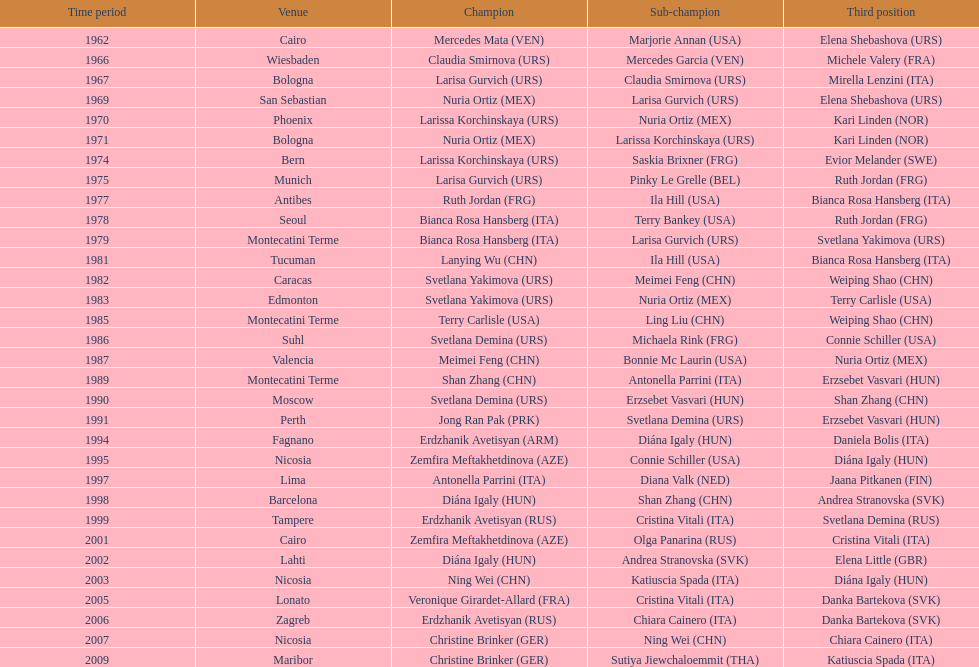Would you mind parsing the complete table? {'header': ['Time period', 'Venue', 'Champion', 'Sub-champion', 'Third position'], 'rows': [['1962', 'Cairo', 'Mercedes Mata\xa0(VEN)', 'Marjorie Annan\xa0(USA)', 'Elena Shebashova\xa0(URS)'], ['1966', 'Wiesbaden', 'Claudia Smirnova\xa0(URS)', 'Mercedes Garcia\xa0(VEN)', 'Michele Valery\xa0(FRA)'], ['1967', 'Bologna', 'Larisa Gurvich\xa0(URS)', 'Claudia Smirnova\xa0(URS)', 'Mirella Lenzini\xa0(ITA)'], ['1969', 'San Sebastian', 'Nuria Ortiz\xa0(MEX)', 'Larisa Gurvich\xa0(URS)', 'Elena Shebashova\xa0(URS)'], ['1970', 'Phoenix', 'Larissa Korchinskaya\xa0(URS)', 'Nuria Ortiz\xa0(MEX)', 'Kari Linden\xa0(NOR)'], ['1971', 'Bologna', 'Nuria Ortiz\xa0(MEX)', 'Larissa Korchinskaya\xa0(URS)', 'Kari Linden\xa0(NOR)'], ['1974', 'Bern', 'Larissa Korchinskaya\xa0(URS)', 'Saskia Brixner\xa0(FRG)', 'Evior Melander\xa0(SWE)'], ['1975', 'Munich', 'Larisa Gurvich\xa0(URS)', 'Pinky Le Grelle\xa0(BEL)', 'Ruth Jordan\xa0(FRG)'], ['1977', 'Antibes', 'Ruth Jordan\xa0(FRG)', 'Ila Hill\xa0(USA)', 'Bianca Rosa Hansberg\xa0(ITA)'], ['1978', 'Seoul', 'Bianca Rosa Hansberg\xa0(ITA)', 'Terry Bankey\xa0(USA)', 'Ruth Jordan\xa0(FRG)'], ['1979', 'Montecatini Terme', 'Bianca Rosa Hansberg\xa0(ITA)', 'Larisa Gurvich\xa0(URS)', 'Svetlana Yakimova\xa0(URS)'], ['1981', 'Tucuman', 'Lanying Wu\xa0(CHN)', 'Ila Hill\xa0(USA)', 'Bianca Rosa Hansberg\xa0(ITA)'], ['1982', 'Caracas', 'Svetlana Yakimova\xa0(URS)', 'Meimei Feng\xa0(CHN)', 'Weiping Shao\xa0(CHN)'], ['1983', 'Edmonton', 'Svetlana Yakimova\xa0(URS)', 'Nuria Ortiz\xa0(MEX)', 'Terry Carlisle\xa0(USA)'], ['1985', 'Montecatini Terme', 'Terry Carlisle\xa0(USA)', 'Ling Liu\xa0(CHN)', 'Weiping Shao\xa0(CHN)'], ['1986', 'Suhl', 'Svetlana Demina\xa0(URS)', 'Michaela Rink\xa0(FRG)', 'Connie Schiller\xa0(USA)'], ['1987', 'Valencia', 'Meimei Feng\xa0(CHN)', 'Bonnie Mc Laurin\xa0(USA)', 'Nuria Ortiz\xa0(MEX)'], ['1989', 'Montecatini Terme', 'Shan Zhang\xa0(CHN)', 'Antonella Parrini\xa0(ITA)', 'Erzsebet Vasvari\xa0(HUN)'], ['1990', 'Moscow', 'Svetlana Demina\xa0(URS)', 'Erzsebet Vasvari\xa0(HUN)', 'Shan Zhang\xa0(CHN)'], ['1991', 'Perth', 'Jong Ran Pak\xa0(PRK)', 'Svetlana Demina\xa0(URS)', 'Erzsebet Vasvari\xa0(HUN)'], ['1994', 'Fagnano', 'Erdzhanik Avetisyan\xa0(ARM)', 'Diána Igaly\xa0(HUN)', 'Daniela Bolis\xa0(ITA)'], ['1995', 'Nicosia', 'Zemfira Meftakhetdinova\xa0(AZE)', 'Connie Schiller\xa0(USA)', 'Diána Igaly\xa0(HUN)'], ['1997', 'Lima', 'Antonella Parrini\xa0(ITA)', 'Diana Valk\xa0(NED)', 'Jaana Pitkanen\xa0(FIN)'], ['1998', 'Barcelona', 'Diána Igaly\xa0(HUN)', 'Shan Zhang\xa0(CHN)', 'Andrea Stranovska\xa0(SVK)'], ['1999', 'Tampere', 'Erdzhanik Avetisyan\xa0(RUS)', 'Cristina Vitali\xa0(ITA)', 'Svetlana Demina\xa0(RUS)'], ['2001', 'Cairo', 'Zemfira Meftakhetdinova\xa0(AZE)', 'Olga Panarina\xa0(RUS)', 'Cristina Vitali\xa0(ITA)'], ['2002', 'Lahti', 'Diána Igaly\xa0(HUN)', 'Andrea Stranovska\xa0(SVK)', 'Elena Little\xa0(GBR)'], ['2003', 'Nicosia', 'Ning Wei\xa0(CHN)', 'Katiuscia Spada\xa0(ITA)', 'Diána Igaly\xa0(HUN)'], ['2005', 'Lonato', 'Veronique Girardet-Allard\xa0(FRA)', 'Cristina Vitali\xa0(ITA)', 'Danka Bartekova\xa0(SVK)'], ['2006', 'Zagreb', 'Erdzhanik Avetisyan\xa0(RUS)', 'Chiara Cainero\xa0(ITA)', 'Danka Bartekova\xa0(SVK)'], ['2007', 'Nicosia', 'Christine Brinker\xa0(GER)', 'Ning Wei\xa0(CHN)', 'Chiara Cainero\xa0(ITA)'], ['2009', 'Maribor', 'Christine Brinker\xa0(GER)', 'Sutiya Jiewchaloemmit\xa0(THA)', 'Katiuscia Spada\xa0(ITA)']]} Which country has won more gold medals: china or mexico? China. 